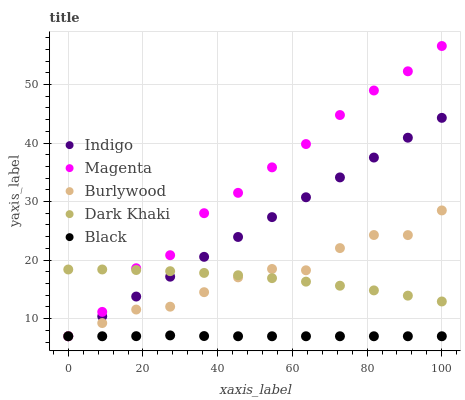Does Black have the minimum area under the curve?
Answer yes or no. Yes. Does Magenta have the maximum area under the curve?
Answer yes or no. Yes. Does Dark Khaki have the minimum area under the curve?
Answer yes or no. No. Does Dark Khaki have the maximum area under the curve?
Answer yes or no. No. Is Indigo the smoothest?
Answer yes or no. Yes. Is Magenta the roughest?
Answer yes or no. Yes. Is Dark Khaki the smoothest?
Answer yes or no. No. Is Dark Khaki the roughest?
Answer yes or no. No. Does Burlywood have the lowest value?
Answer yes or no. Yes. Does Dark Khaki have the lowest value?
Answer yes or no. No. Does Magenta have the highest value?
Answer yes or no. Yes. Does Dark Khaki have the highest value?
Answer yes or no. No. Is Black less than Dark Khaki?
Answer yes or no. Yes. Is Dark Khaki greater than Black?
Answer yes or no. Yes. Does Magenta intersect Black?
Answer yes or no. Yes. Is Magenta less than Black?
Answer yes or no. No. Is Magenta greater than Black?
Answer yes or no. No. Does Black intersect Dark Khaki?
Answer yes or no. No. 